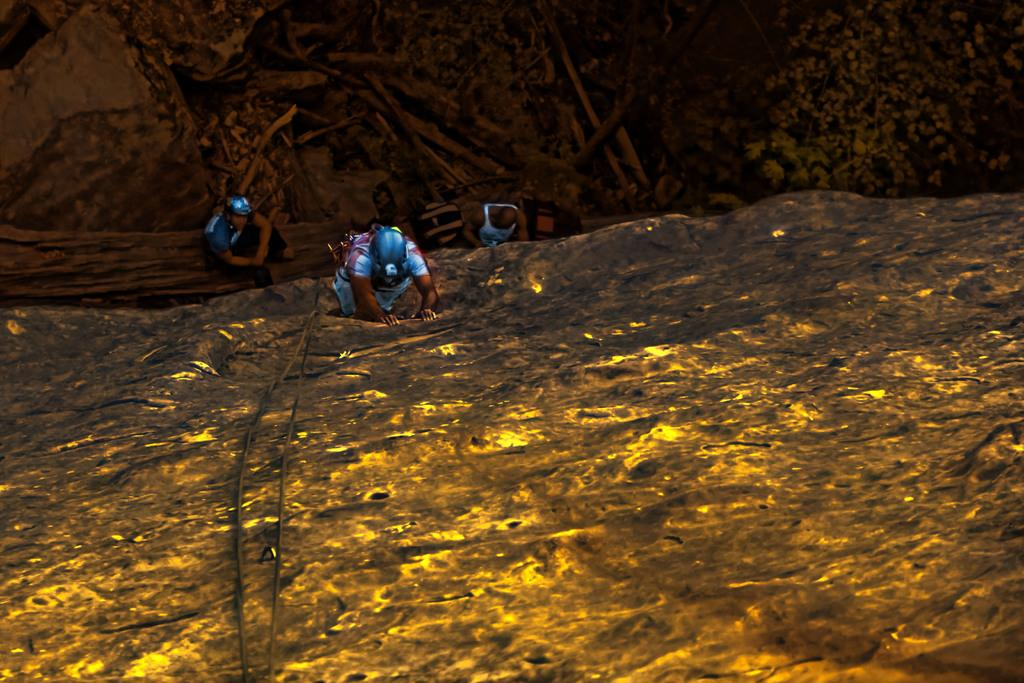How many people are wearing helmets in the image? There are two people wearing helmets in the image. Can you describe the person in the image? There is a person in the image, but no specific details are provided about their appearance or actions. What type of items can be seen in the image? There are bags, wooden objects, plants, rocks, and ropes in the image. How many sisters are present in the image? There is no mention of a sister in the image, so it cannot be determined if any are present. What type of plantation can be seen in the image? There is no plantation present in the image; it features people, bags, wooden objects, plants, rocks, and ropes. 